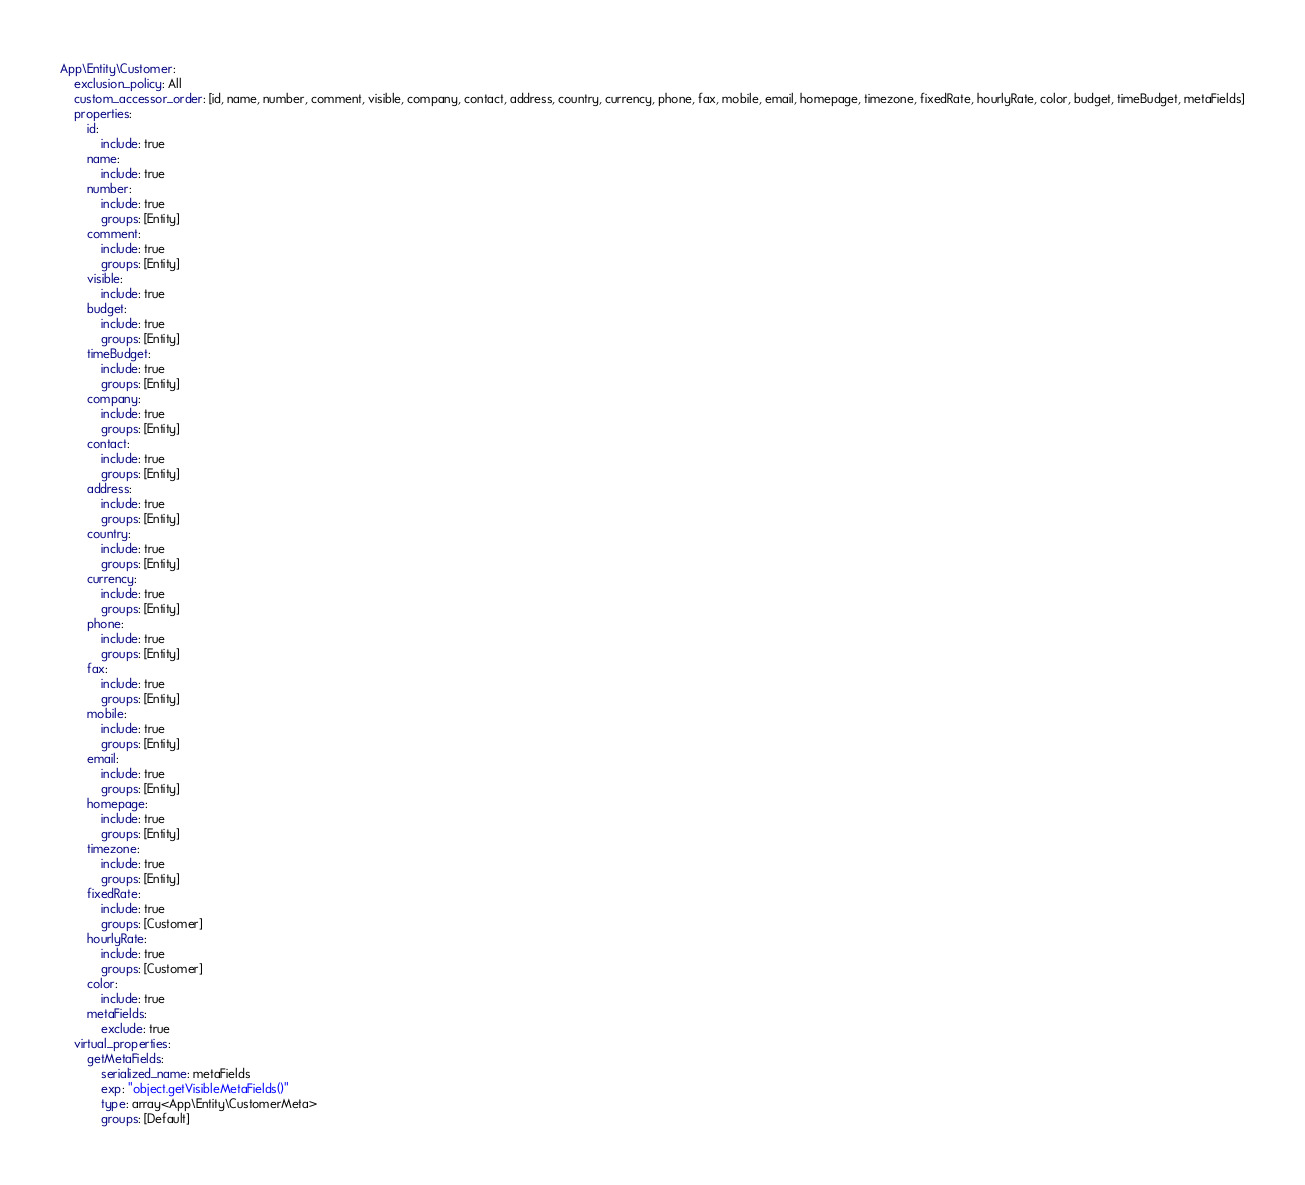<code> <loc_0><loc_0><loc_500><loc_500><_YAML_>App\Entity\Customer:
    exclusion_policy: All
    custom_accessor_order: [id, name, number, comment, visible, company, contact, address, country, currency, phone, fax, mobile, email, homepage, timezone, fixedRate, hourlyRate, color, budget, timeBudget, metaFields]
    properties:
        id:
            include: true
        name:
            include: true
        number:
            include: true
            groups: [Entity]
        comment:
            include: true
            groups: [Entity]
        visible:
            include: true
        budget:
            include: true
            groups: [Entity]
        timeBudget:
            include: true
            groups: [Entity]
        company:
            include: true
            groups: [Entity]
        contact:
            include: true
            groups: [Entity]
        address:
            include: true
            groups: [Entity]
        country:
            include: true
            groups: [Entity]
        currency:
            include: true
            groups: [Entity]
        phone:
            include: true
            groups: [Entity]
        fax:
            include: true
            groups: [Entity]
        mobile:
            include: true
            groups: [Entity]
        email:
            include: true
            groups: [Entity]
        homepage:
            include: true
            groups: [Entity]
        timezone:
            include: true
            groups: [Entity]
        fixedRate:
            include: true
            groups: [Customer]
        hourlyRate:
            include: true
            groups: [Customer]
        color:
            include: true
        metaFields:
            exclude: true
    virtual_properties:
        getMetaFields:
            serialized_name: metaFields
            exp: "object.getVisibleMetaFields()"
            type: array<App\Entity\CustomerMeta>
            groups: [Default]
</code> 